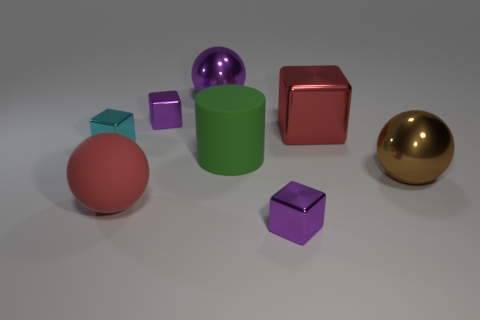Subtract 1 cubes. How many cubes are left? 3 Add 1 large yellow cylinders. How many objects exist? 9 Subtract all balls. How many objects are left? 5 Add 7 purple shiny blocks. How many purple shiny blocks are left? 9 Add 1 small cyan shiny objects. How many small cyan shiny objects exist? 2 Subtract 0 green balls. How many objects are left? 8 Subtract all small blue metallic cylinders. Subtract all large brown metallic balls. How many objects are left? 7 